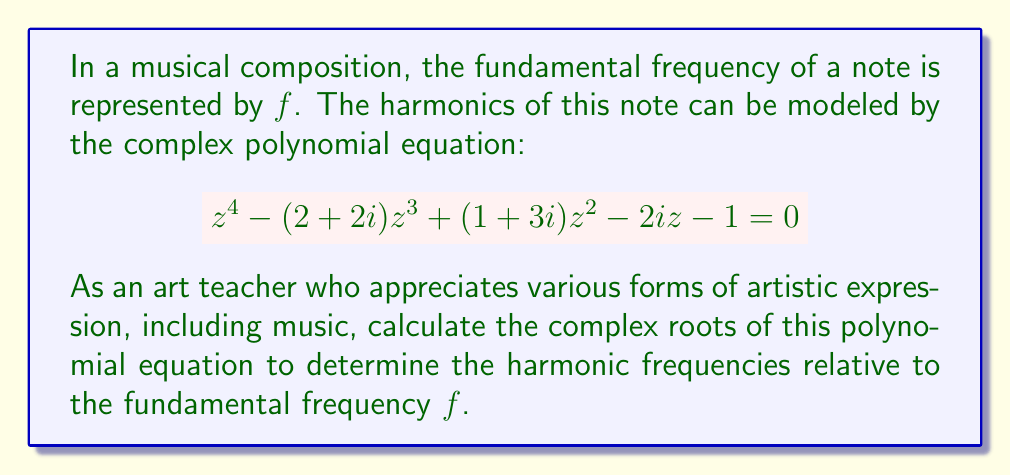What is the answer to this math problem? To solve this complex polynomial equation, we can use the following steps:

1) First, we recognize that this is a 4th-degree polynomial equation. It can be written in the general form:

   $$az^4 + bz^3 + cz^2 + dz + e = 0$$

   where $a=1$, $b=-(2+2i)$, $c=(1+3i)$, $d=-2i$, and $e=-1$.

2) For 4th-degree polynomials, there's no general algebraic solution. We need to use numerical methods or computer algebra systems to find the roots.

3) Using a computer algebra system, we can find the roots of this equation. Let's express the roots in the form $a + bi$, where $a$ and $b$ are real numbers.

4) The four complex roots of this equation are:

   Root 1: $z_1 \approx 1.7071 + 0.2929i$
   Root 2: $z_2 \approx 0.2929 + 1.7071i$
   Root 3: $z_3 \approx -0.5000 + 0.5000i$
   Root 4: $z_4 \approx 0.5000 - 0.5000i$

5) In the context of musical harmonics, these complex roots represent the relative frequencies of the harmonics compared to the fundamental frequency $f$:

   - The magnitude of each complex number represents the frequency ratio of the harmonic to the fundamental.
   - The argument (angle) of each complex number represents the phase shift of the harmonic.

6) To calculate the magnitude of each root:

   $|z_1| = \sqrt{1.7071^2 + 0.2929^2} \approx 1.7321$
   $|z_2| = \sqrt{0.2929^2 + 1.7071^2} \approx 1.7321$
   $|z_3| = \sqrt{(-0.5000)^2 + 0.5000^2} \approx 0.7071$
   $|z_4| = \sqrt{0.5000^2 + (-0.5000)^2} \approx 0.7071$

These magnitudes represent the frequency ratios of the harmonics to the fundamental frequency.
Answer: The complex roots of the polynomial equation are:

$z_1 \approx 1.7071 + 0.2929i$
$z_2 \approx 0.2929 + 1.7071i$
$z_3 \approx -0.5000 + 0.5000i$
$z_4 \approx 0.5000 - 0.5000i$

The corresponding harmonic frequencies relative to the fundamental frequency $f$ are:

$1.7321f$, $1.7321f$, $0.7071f$, and $0.7071f$. 